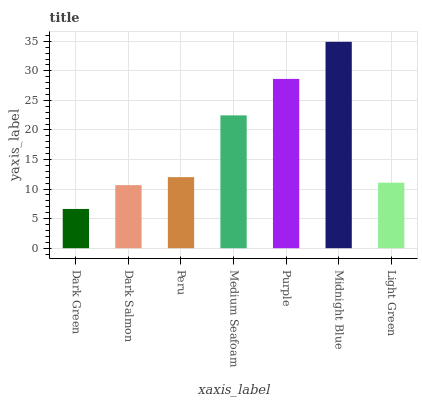Is Dark Green the minimum?
Answer yes or no. Yes. Is Midnight Blue the maximum?
Answer yes or no. Yes. Is Dark Salmon the minimum?
Answer yes or no. No. Is Dark Salmon the maximum?
Answer yes or no. No. Is Dark Salmon greater than Dark Green?
Answer yes or no. Yes. Is Dark Green less than Dark Salmon?
Answer yes or no. Yes. Is Dark Green greater than Dark Salmon?
Answer yes or no. No. Is Dark Salmon less than Dark Green?
Answer yes or no. No. Is Peru the high median?
Answer yes or no. Yes. Is Peru the low median?
Answer yes or no. Yes. Is Dark Green the high median?
Answer yes or no. No. Is Dark Green the low median?
Answer yes or no. No. 